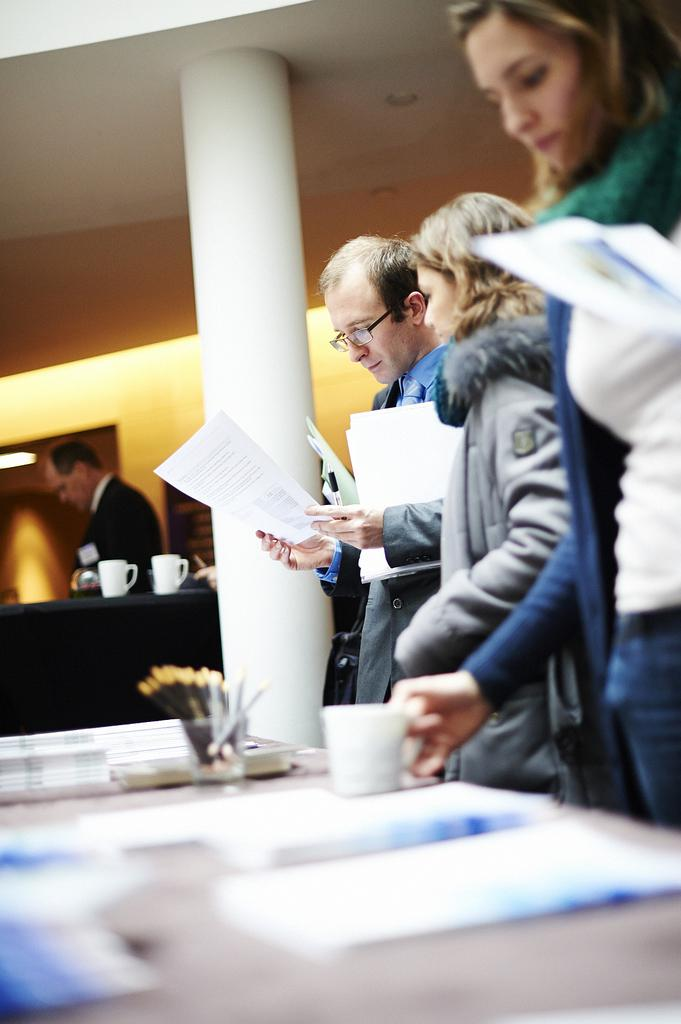What are the persons in the image doing? The persons in the image are standing and holding papers. What else can be seen on the table besides the persons? There are papers and a cup on the table. What is the color of the pillar in the image? The pillar in the image is white. Who is holding a cup in the image? A woman is holding a cup in the image. How many persons are standing close to each other in the image? There is one person standing far from the others in the image. What type of waste can be seen in the image? There is no waste present in the image. What kind of rail is visible in the image? There is no rail present in the image. 